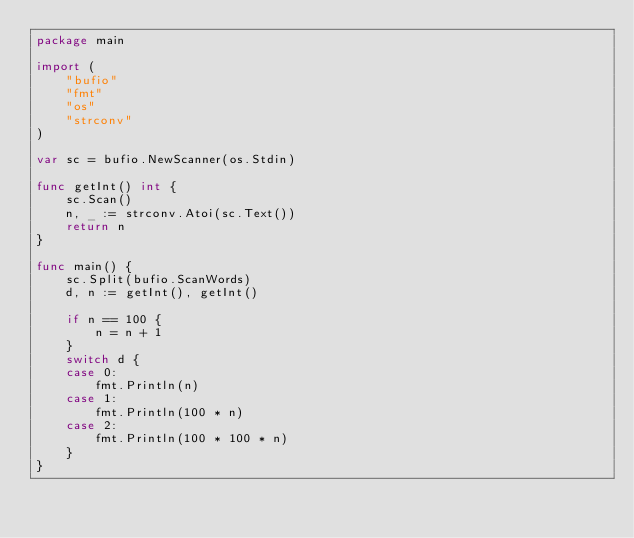<code> <loc_0><loc_0><loc_500><loc_500><_Go_>package main

import (
	"bufio"
	"fmt"
	"os"
	"strconv"
)

var sc = bufio.NewScanner(os.Stdin)

func getInt() int {
	sc.Scan()
	n, _ := strconv.Atoi(sc.Text())
	return n
}

func main() {
	sc.Split(bufio.ScanWords)
	d, n := getInt(), getInt()

	if n == 100 {
		n = n + 1
	}
	switch d {
	case 0:
		fmt.Println(n)
	case 1:
		fmt.Println(100 * n)
	case 2:
		fmt.Println(100 * 100 * n)
	}
}
</code> 